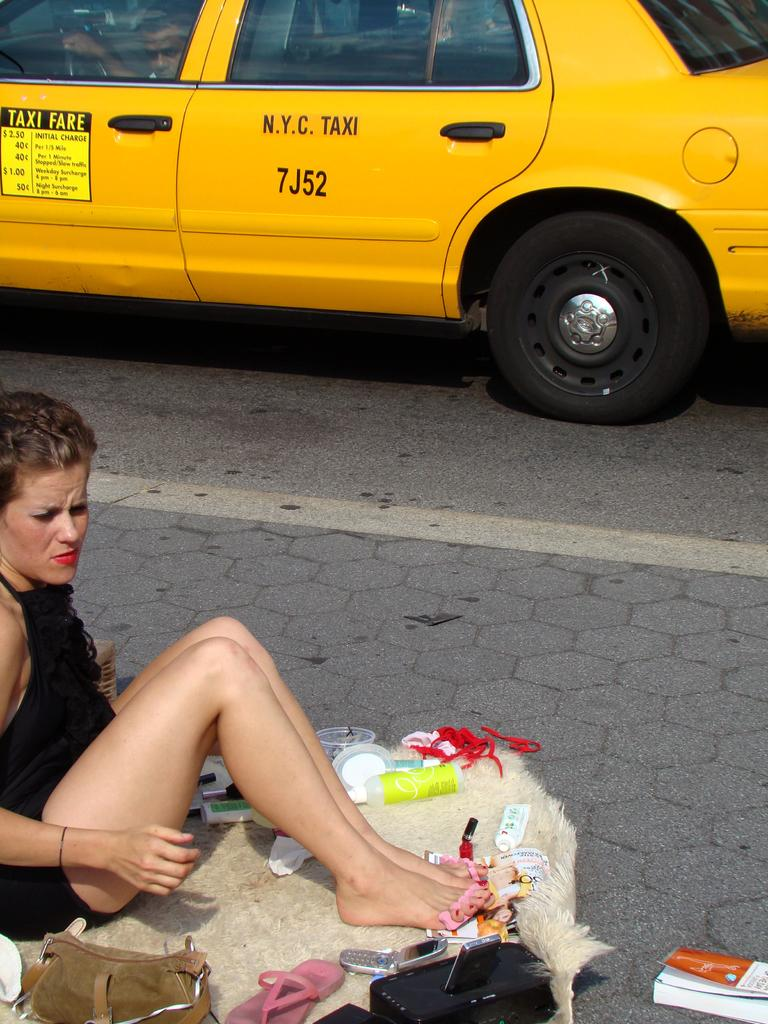Provide a one-sentence caption for the provided image. Taxi fares are listed on the front driver side door of the cab. 